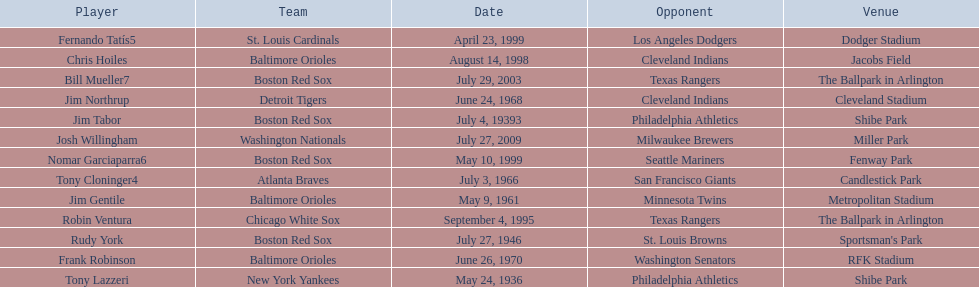What is the name of the player for the new york yankees in 1936? Tony Lazzeri. 